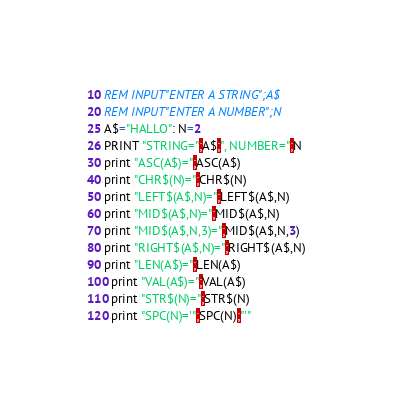Convert code to text. <code><loc_0><loc_0><loc_500><loc_500><_VisualBasic_>10 REM INPUT"ENTER A STRING";A$
20 REM INPUT"ENTER A NUMBER";N
25 A$="HALLO": N=2
26 PRINT "STRING=";A$;", NUMBER=";N
30 print "ASC(A$)=";ASC(A$)
40 print "CHR$(N)=";CHR$(N)
50 print "LEFT$(A$,N)=";LEFT$(A$,N)
60 print "MID$(A$,N)=";MID$(A$,N)
70 print "MID$(A$,N,3)=";MID$(A$,N,3)
80 print "RIGHT$(A$,N)=";RIGHT$(A$,N)
90 print "LEN(A$)=";LEN(A$)
100 print "VAL(A$)=";VAL(A$)
110 print "STR$(N)=";STR$(N)
120 print "SPC(N)='";SPC(N);"'"
</code> 